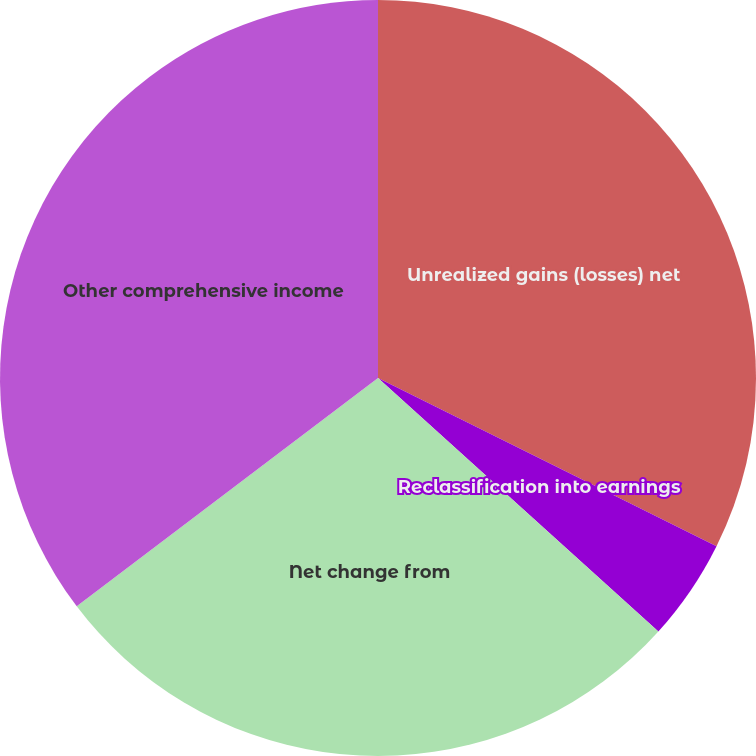Convert chart. <chart><loc_0><loc_0><loc_500><loc_500><pie_chart><fcel>Unrealized gains (losses) net<fcel>Reclassification into earnings<fcel>Net change from<fcel>Other comprehensive income<nl><fcel>32.34%<fcel>4.36%<fcel>27.98%<fcel>35.32%<nl></chart> 